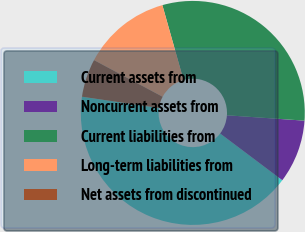Convert chart to OTSL. <chart><loc_0><loc_0><loc_500><loc_500><pie_chart><fcel>Current assets from<fcel>Noncurrent assets from<fcel>Current liabilities from<fcel>Long-term liabilities from<fcel>Net assets from discontinued<nl><fcel>42.05%<fcel>9.16%<fcel>30.48%<fcel>12.81%<fcel>5.5%<nl></chart> 